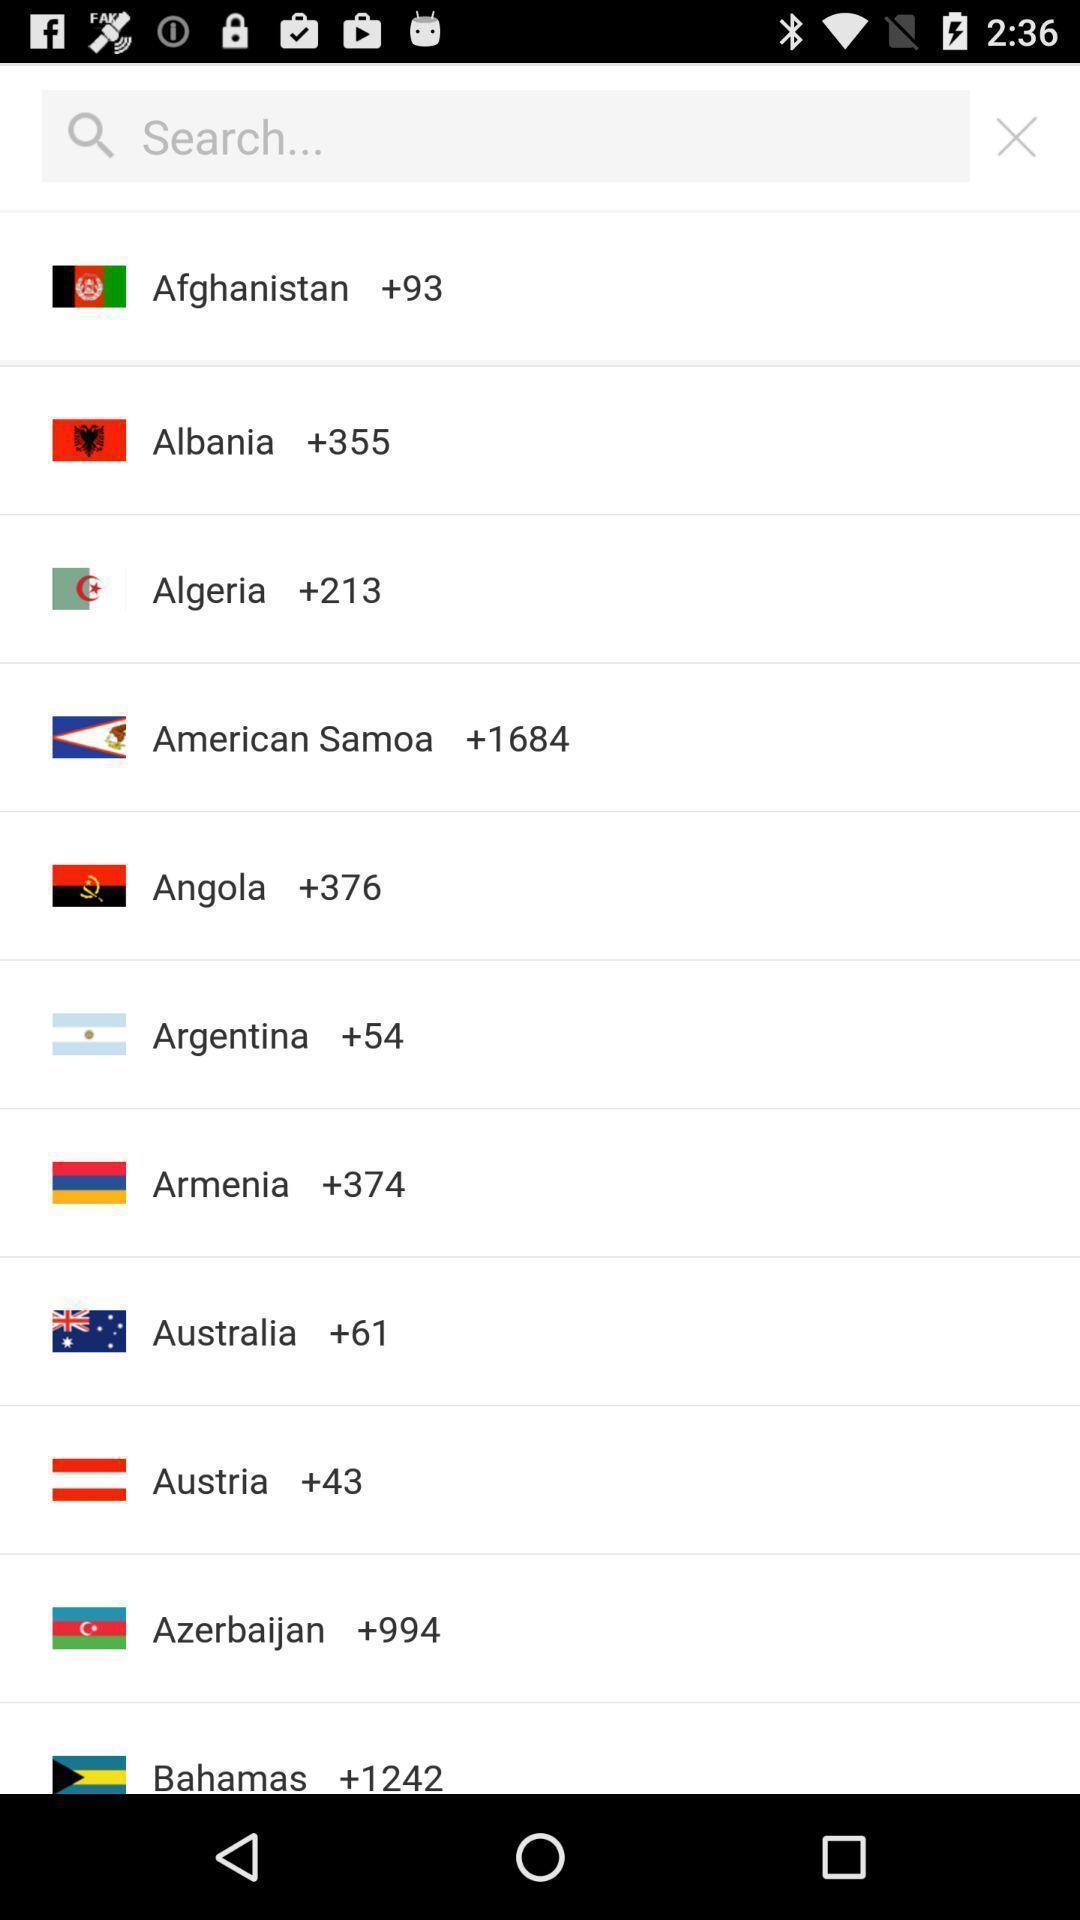Describe the key features of this screenshot. Screen displaying search bar to search for a country. 